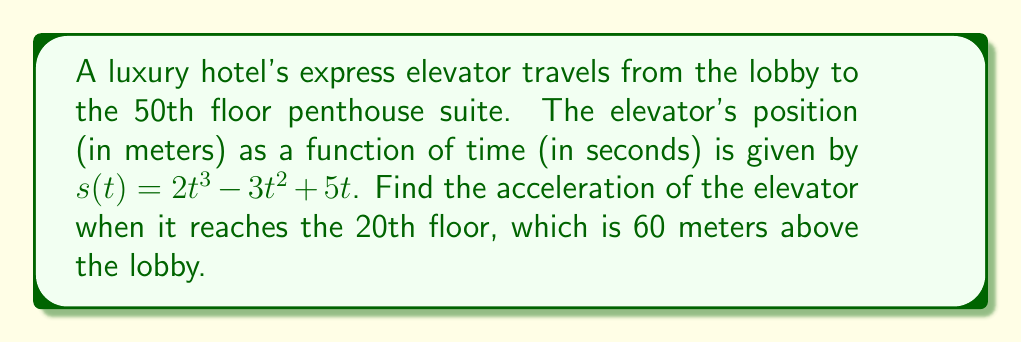What is the answer to this math problem? To find the acceleration of the elevator, we need to follow these steps:

1. The position function is given as $s(t) = 2t^3 - 3t^2 + 5t$

2. To find velocity, we take the first derivative of the position function:
   $v(t) = s'(t) = 6t^2 - 6t + 5$

3. To find acceleration, we take the second derivative of the position function (or the first derivative of the velocity function):
   $a(t) = v'(t) = s''(t) = 12t - 6$

4. We need to find the time $t$ when the elevator reaches the 20th floor (60 meters above the lobby):
   $60 = 2t^3 - 3t^2 + 5t$

   This is a cubic equation. We can solve it by trial and error or using a graphing calculator. The solution is approximately $t = 3.464$ seconds.

5. Now we can substitute this time into the acceleration function:
   $a(3.464) = 12(3.464) - 6 = 41.568 - 6 = 35.568$

Therefore, the acceleration of the elevator when it reaches the 20th floor is approximately 35.568 m/s².
Answer: $35.568$ m/s² 